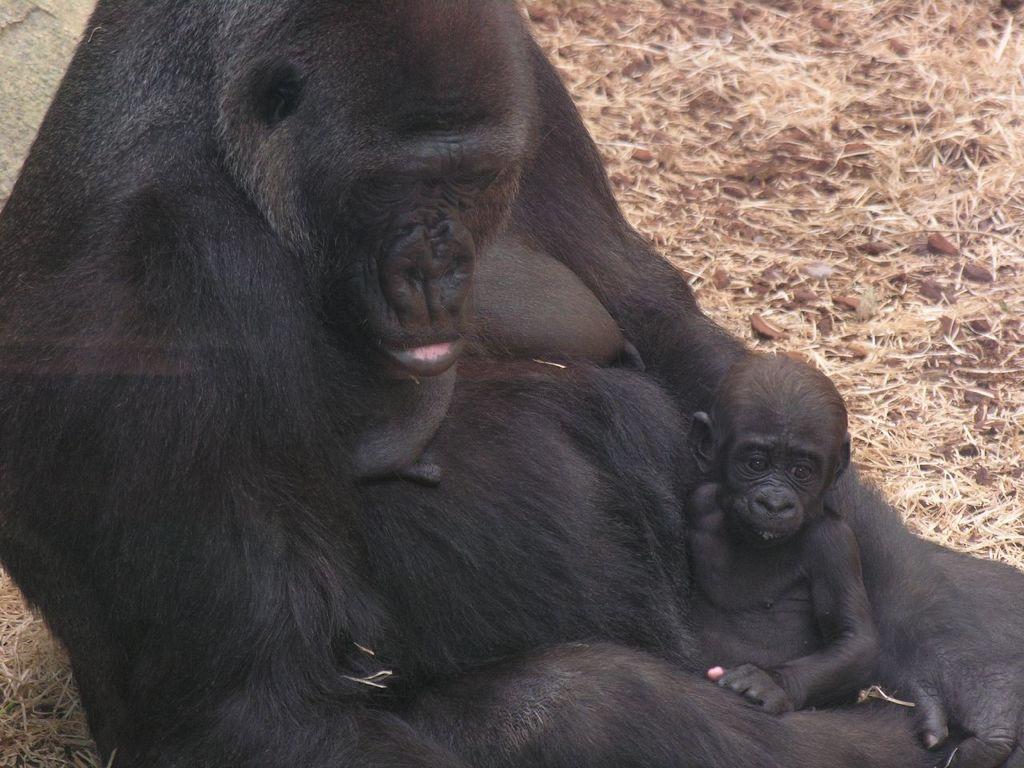Please provide a concise description of this image. There is a chimpanzee with a baby chimpanzee. 